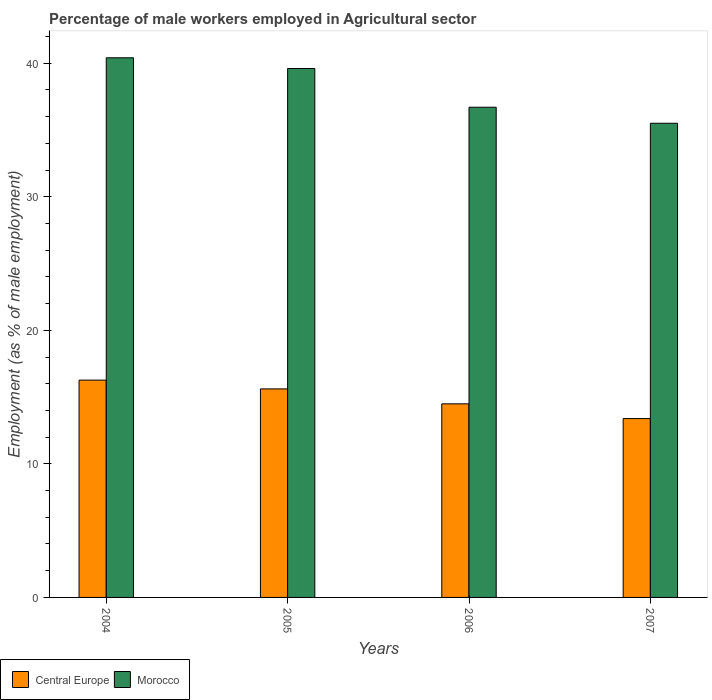How many groups of bars are there?
Give a very brief answer. 4. Are the number of bars per tick equal to the number of legend labels?
Give a very brief answer. Yes. How many bars are there on the 3rd tick from the left?
Your response must be concise. 2. How many bars are there on the 2nd tick from the right?
Keep it short and to the point. 2. In how many cases, is the number of bars for a given year not equal to the number of legend labels?
Keep it short and to the point. 0. What is the percentage of male workers employed in Agricultural sector in Morocco in 2005?
Offer a very short reply. 39.6. Across all years, what is the maximum percentage of male workers employed in Agricultural sector in Central Europe?
Give a very brief answer. 16.27. Across all years, what is the minimum percentage of male workers employed in Agricultural sector in Morocco?
Your answer should be very brief. 35.5. What is the total percentage of male workers employed in Agricultural sector in Morocco in the graph?
Provide a succinct answer. 152.2. What is the difference between the percentage of male workers employed in Agricultural sector in Central Europe in 2004 and that in 2007?
Offer a very short reply. 2.88. What is the difference between the percentage of male workers employed in Agricultural sector in Central Europe in 2007 and the percentage of male workers employed in Agricultural sector in Morocco in 2006?
Offer a very short reply. -23.31. What is the average percentage of male workers employed in Agricultural sector in Central Europe per year?
Provide a short and direct response. 14.94. In the year 2006, what is the difference between the percentage of male workers employed in Agricultural sector in Morocco and percentage of male workers employed in Agricultural sector in Central Europe?
Ensure brevity in your answer.  22.21. In how many years, is the percentage of male workers employed in Agricultural sector in Morocco greater than 12 %?
Offer a terse response. 4. What is the ratio of the percentage of male workers employed in Agricultural sector in Central Europe in 2006 to that in 2007?
Provide a succinct answer. 1.08. What is the difference between the highest and the second highest percentage of male workers employed in Agricultural sector in Central Europe?
Make the answer very short. 0.66. What is the difference between the highest and the lowest percentage of male workers employed in Agricultural sector in Morocco?
Make the answer very short. 4.9. In how many years, is the percentage of male workers employed in Agricultural sector in Morocco greater than the average percentage of male workers employed in Agricultural sector in Morocco taken over all years?
Your answer should be very brief. 2. What does the 1st bar from the left in 2007 represents?
Your response must be concise. Central Europe. What does the 1st bar from the right in 2007 represents?
Provide a short and direct response. Morocco. How many bars are there?
Provide a succinct answer. 8. Are all the bars in the graph horizontal?
Provide a succinct answer. No. How many years are there in the graph?
Make the answer very short. 4. Does the graph contain any zero values?
Provide a short and direct response. No. Where does the legend appear in the graph?
Provide a short and direct response. Bottom left. How many legend labels are there?
Keep it short and to the point. 2. How are the legend labels stacked?
Offer a terse response. Horizontal. What is the title of the graph?
Provide a short and direct response. Percentage of male workers employed in Agricultural sector. What is the label or title of the Y-axis?
Provide a short and direct response. Employment (as % of male employment). What is the Employment (as % of male employment) in Central Europe in 2004?
Provide a succinct answer. 16.27. What is the Employment (as % of male employment) of Morocco in 2004?
Give a very brief answer. 40.4. What is the Employment (as % of male employment) in Central Europe in 2005?
Your response must be concise. 15.61. What is the Employment (as % of male employment) of Morocco in 2005?
Give a very brief answer. 39.6. What is the Employment (as % of male employment) of Central Europe in 2006?
Your answer should be compact. 14.49. What is the Employment (as % of male employment) in Morocco in 2006?
Give a very brief answer. 36.7. What is the Employment (as % of male employment) of Central Europe in 2007?
Give a very brief answer. 13.39. What is the Employment (as % of male employment) in Morocco in 2007?
Give a very brief answer. 35.5. Across all years, what is the maximum Employment (as % of male employment) in Central Europe?
Your answer should be compact. 16.27. Across all years, what is the maximum Employment (as % of male employment) of Morocco?
Your answer should be compact. 40.4. Across all years, what is the minimum Employment (as % of male employment) in Central Europe?
Your response must be concise. 13.39. Across all years, what is the minimum Employment (as % of male employment) of Morocco?
Your response must be concise. 35.5. What is the total Employment (as % of male employment) of Central Europe in the graph?
Your response must be concise. 59.76. What is the total Employment (as % of male employment) of Morocco in the graph?
Offer a terse response. 152.2. What is the difference between the Employment (as % of male employment) in Central Europe in 2004 and that in 2005?
Keep it short and to the point. 0.66. What is the difference between the Employment (as % of male employment) in Central Europe in 2004 and that in 2006?
Offer a terse response. 1.78. What is the difference between the Employment (as % of male employment) of Central Europe in 2004 and that in 2007?
Provide a succinct answer. 2.88. What is the difference between the Employment (as % of male employment) in Central Europe in 2005 and that in 2006?
Your answer should be compact. 1.12. What is the difference between the Employment (as % of male employment) in Morocco in 2005 and that in 2006?
Your answer should be compact. 2.9. What is the difference between the Employment (as % of male employment) in Central Europe in 2005 and that in 2007?
Provide a short and direct response. 2.22. What is the difference between the Employment (as % of male employment) of Morocco in 2005 and that in 2007?
Offer a terse response. 4.1. What is the difference between the Employment (as % of male employment) in Central Europe in 2006 and that in 2007?
Provide a short and direct response. 1.11. What is the difference between the Employment (as % of male employment) of Central Europe in 2004 and the Employment (as % of male employment) of Morocco in 2005?
Give a very brief answer. -23.33. What is the difference between the Employment (as % of male employment) in Central Europe in 2004 and the Employment (as % of male employment) in Morocco in 2006?
Keep it short and to the point. -20.43. What is the difference between the Employment (as % of male employment) in Central Europe in 2004 and the Employment (as % of male employment) in Morocco in 2007?
Offer a terse response. -19.23. What is the difference between the Employment (as % of male employment) in Central Europe in 2005 and the Employment (as % of male employment) in Morocco in 2006?
Offer a terse response. -21.09. What is the difference between the Employment (as % of male employment) of Central Europe in 2005 and the Employment (as % of male employment) of Morocco in 2007?
Provide a succinct answer. -19.89. What is the difference between the Employment (as % of male employment) in Central Europe in 2006 and the Employment (as % of male employment) in Morocco in 2007?
Keep it short and to the point. -21.01. What is the average Employment (as % of male employment) in Central Europe per year?
Make the answer very short. 14.94. What is the average Employment (as % of male employment) in Morocco per year?
Your response must be concise. 38.05. In the year 2004, what is the difference between the Employment (as % of male employment) in Central Europe and Employment (as % of male employment) in Morocco?
Provide a succinct answer. -24.13. In the year 2005, what is the difference between the Employment (as % of male employment) of Central Europe and Employment (as % of male employment) of Morocco?
Give a very brief answer. -23.99. In the year 2006, what is the difference between the Employment (as % of male employment) of Central Europe and Employment (as % of male employment) of Morocco?
Your answer should be compact. -22.21. In the year 2007, what is the difference between the Employment (as % of male employment) of Central Europe and Employment (as % of male employment) of Morocco?
Offer a very short reply. -22.11. What is the ratio of the Employment (as % of male employment) of Central Europe in 2004 to that in 2005?
Your answer should be very brief. 1.04. What is the ratio of the Employment (as % of male employment) in Morocco in 2004 to that in 2005?
Your answer should be very brief. 1.02. What is the ratio of the Employment (as % of male employment) of Central Europe in 2004 to that in 2006?
Provide a succinct answer. 1.12. What is the ratio of the Employment (as % of male employment) in Morocco in 2004 to that in 2006?
Your response must be concise. 1.1. What is the ratio of the Employment (as % of male employment) of Central Europe in 2004 to that in 2007?
Your answer should be very brief. 1.22. What is the ratio of the Employment (as % of male employment) of Morocco in 2004 to that in 2007?
Offer a terse response. 1.14. What is the ratio of the Employment (as % of male employment) in Central Europe in 2005 to that in 2006?
Your answer should be very brief. 1.08. What is the ratio of the Employment (as % of male employment) of Morocco in 2005 to that in 2006?
Offer a terse response. 1.08. What is the ratio of the Employment (as % of male employment) of Central Europe in 2005 to that in 2007?
Your answer should be very brief. 1.17. What is the ratio of the Employment (as % of male employment) of Morocco in 2005 to that in 2007?
Your answer should be compact. 1.12. What is the ratio of the Employment (as % of male employment) in Central Europe in 2006 to that in 2007?
Make the answer very short. 1.08. What is the ratio of the Employment (as % of male employment) of Morocco in 2006 to that in 2007?
Offer a very short reply. 1.03. What is the difference between the highest and the second highest Employment (as % of male employment) of Central Europe?
Provide a succinct answer. 0.66. What is the difference between the highest and the second highest Employment (as % of male employment) in Morocco?
Offer a very short reply. 0.8. What is the difference between the highest and the lowest Employment (as % of male employment) in Central Europe?
Your response must be concise. 2.88. 